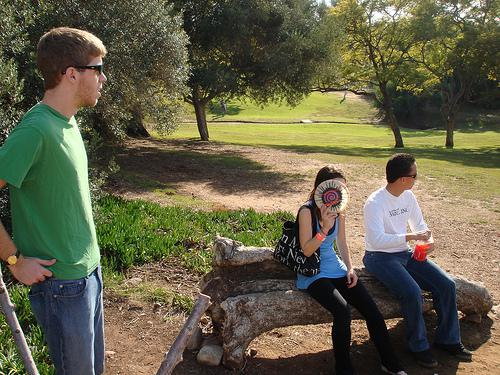Question: how is the girl sitting?
Choices:
A. Cross legged.
B. Slough on the tree trunk.
C. On a bench.
D. On a tree limb.
Answer with the letter. Answer: B Question: where is her face?
Choices:
A. Behind the fan.
B. Behind the disk.
C. Up high.
D. Down low.
Answer with the letter. Answer: B 